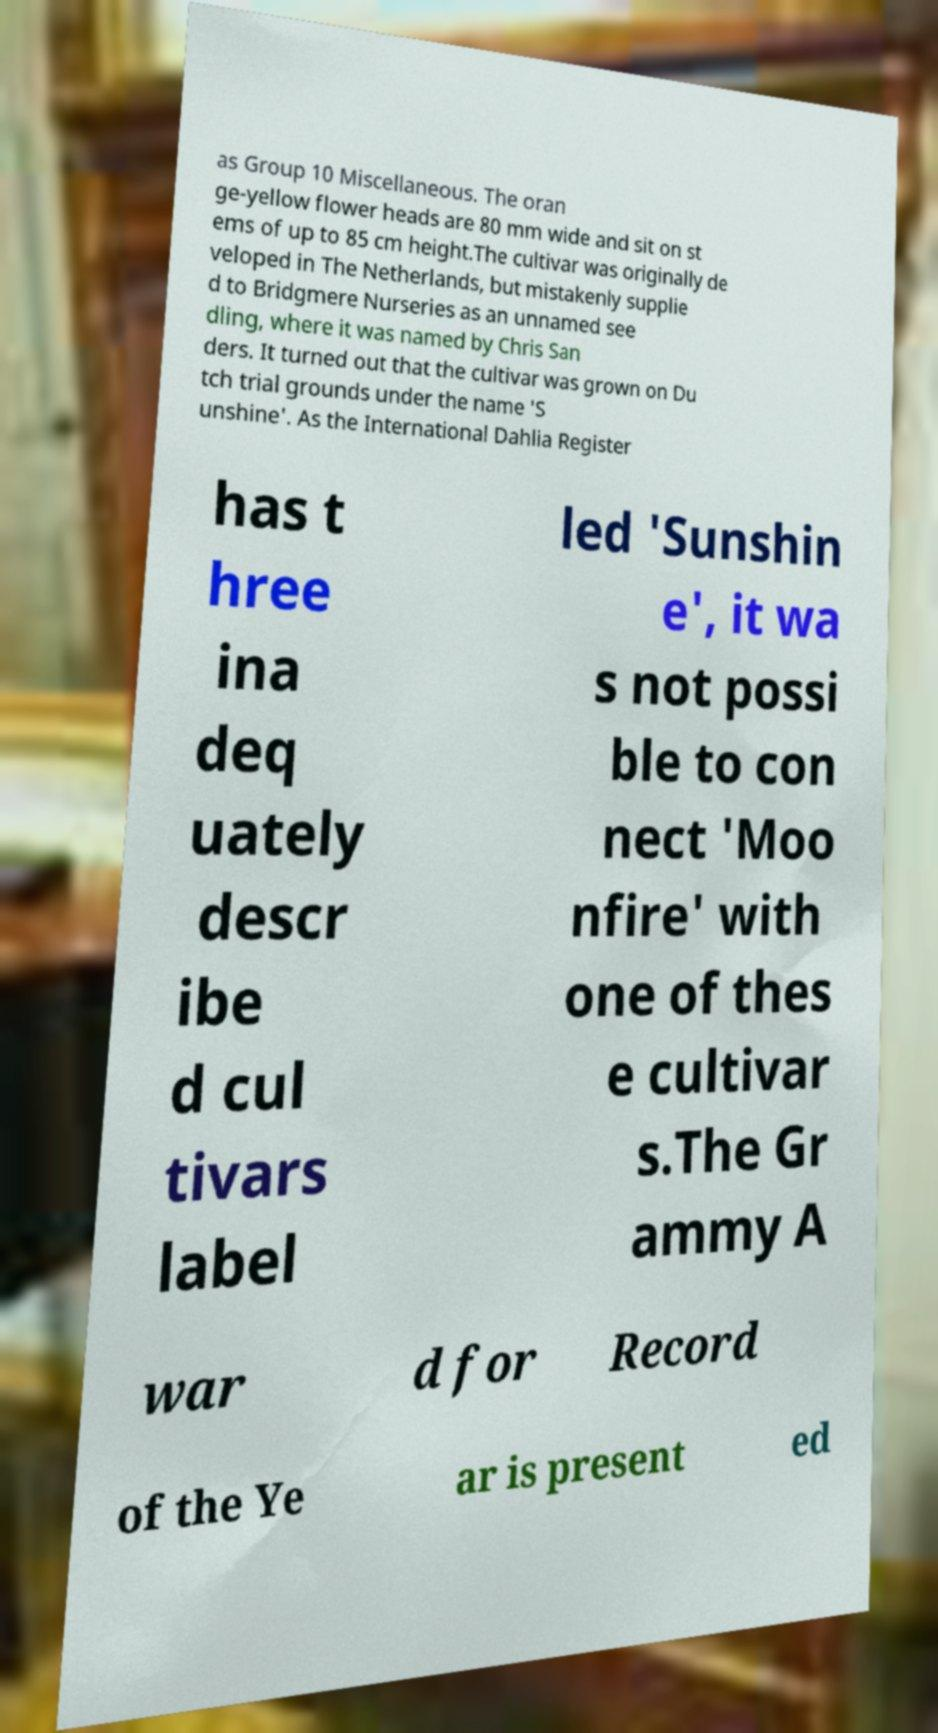Please read and relay the text visible in this image. What does it say? as Group 10 Miscellaneous. The oran ge-yellow flower heads are 80 mm wide and sit on st ems of up to 85 cm height.The cultivar was originally de veloped in The Netherlands, but mistakenly supplie d to Bridgmere Nurseries as an unnamed see dling, where it was named by Chris San ders. It turned out that the cultivar was grown on Du tch trial grounds under the name 'S unshine'. As the International Dahlia Register has t hree ina deq uately descr ibe d cul tivars label led 'Sunshin e', it wa s not possi ble to con nect 'Moo nfire' with one of thes e cultivar s.The Gr ammy A war d for Record of the Ye ar is present ed 